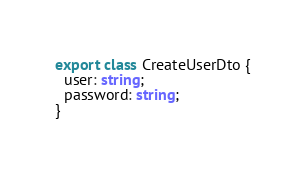<code> <loc_0><loc_0><loc_500><loc_500><_TypeScript_>export class CreateUserDto {
  user: string;
  password: string;
}
</code> 